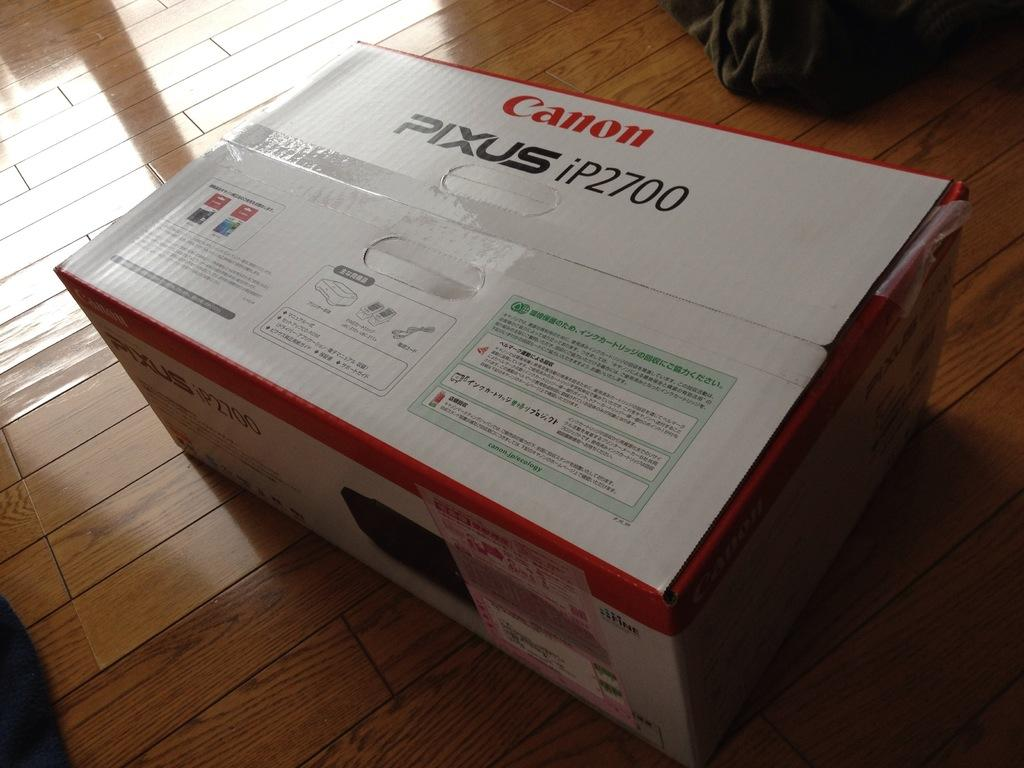<image>
Relay a brief, clear account of the picture shown. A box that consists of a Canan Pixus ip2700. 